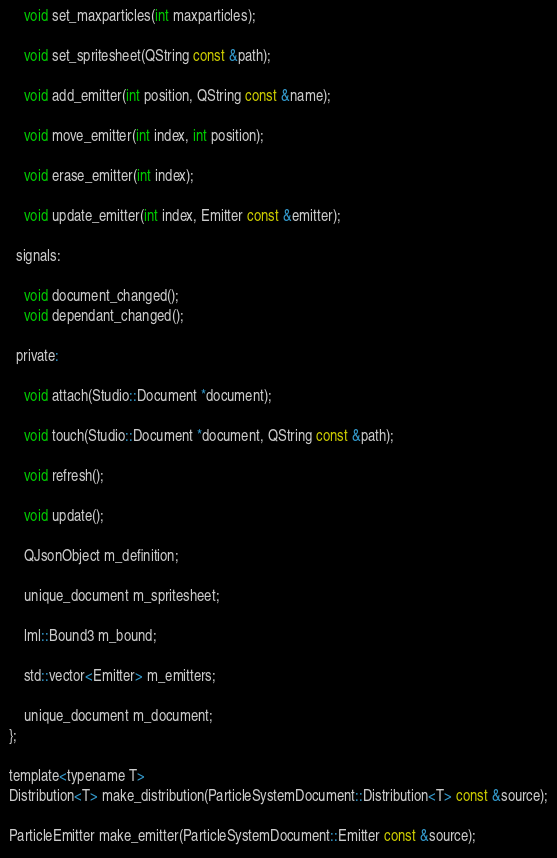<code> <loc_0><loc_0><loc_500><loc_500><_C_>    void set_maxparticles(int maxparticles);

    void set_spritesheet(QString const &path);

    void add_emitter(int position, QString const &name);

    void move_emitter(int index, int position);

    void erase_emitter(int index);

    void update_emitter(int index, Emitter const &emitter);

  signals:

    void document_changed();
    void dependant_changed();

  private:

    void attach(Studio::Document *document);

    void touch(Studio::Document *document, QString const &path);

    void refresh();

    void update();

    QJsonObject m_definition;

    unique_document m_spritesheet;

    lml::Bound3 m_bound;

    std::vector<Emitter> m_emitters;

    unique_document m_document;
};

template<typename T>
Distribution<T> make_distribution(ParticleSystemDocument::Distribution<T> const &source);

ParticleEmitter make_emitter(ParticleSystemDocument::Emitter const &source);
</code> 